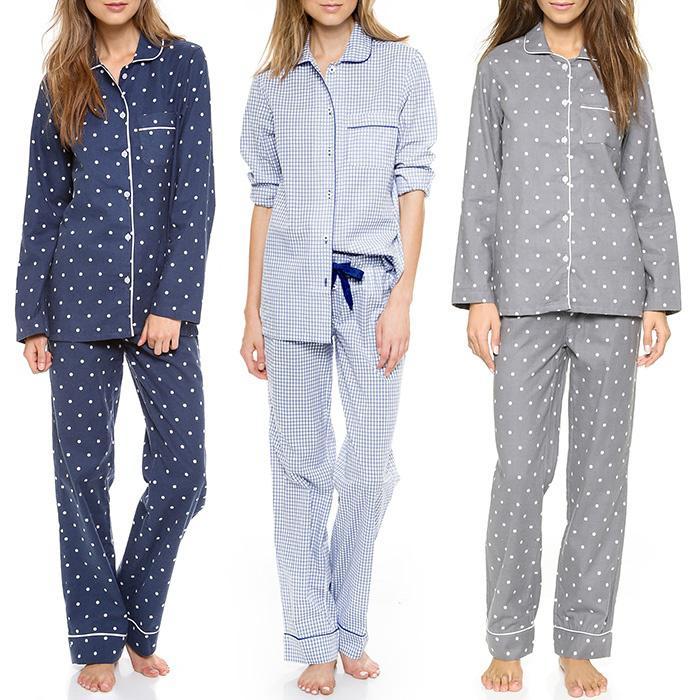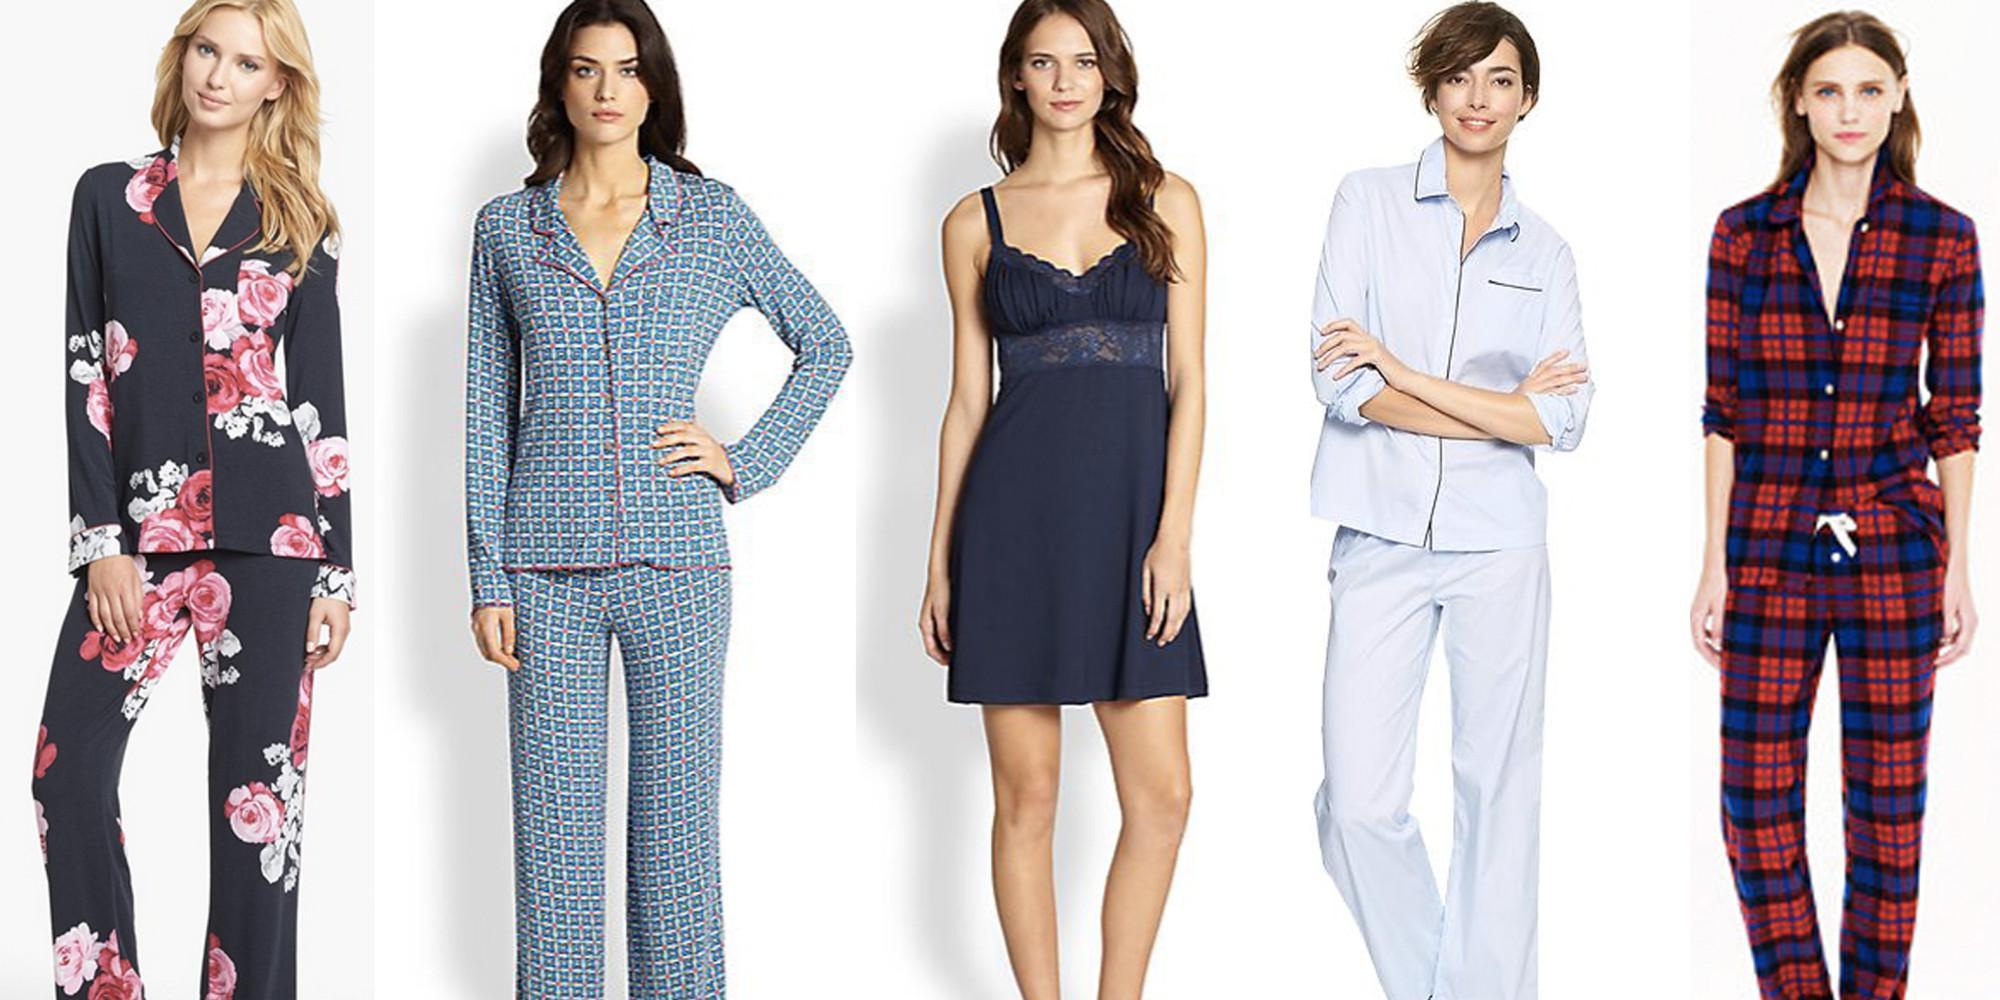The first image is the image on the left, the second image is the image on the right. Examine the images to the left and right. Is the description "there are models with legs showing" accurate? Answer yes or no. Yes. The first image is the image on the left, the second image is the image on the right. For the images shown, is this caption "An image shows three models side-by-side, all wearing long-legged loungewear." true? Answer yes or no. Yes. 